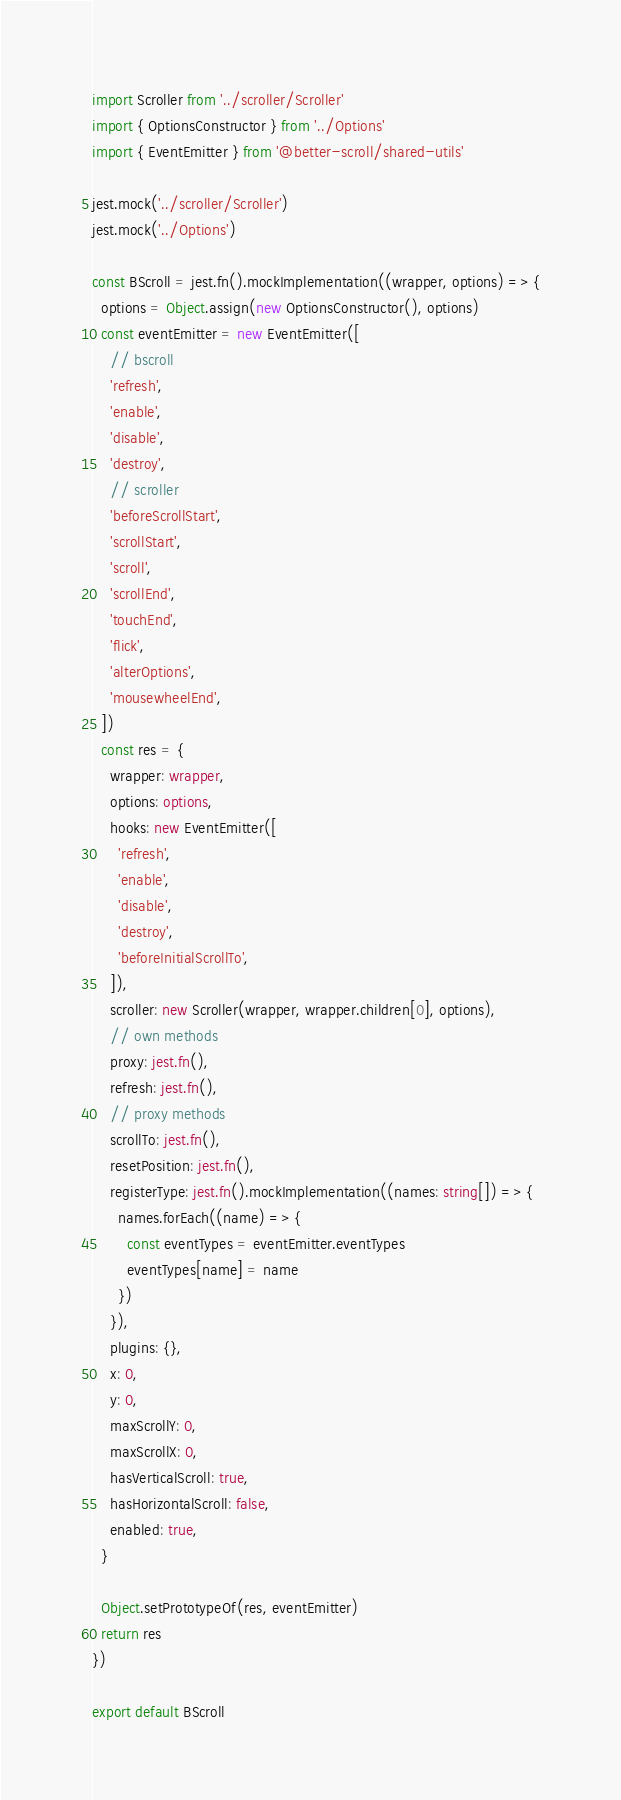<code> <loc_0><loc_0><loc_500><loc_500><_TypeScript_>import Scroller from '../scroller/Scroller'
import { OptionsConstructor } from '../Options'
import { EventEmitter } from '@better-scroll/shared-utils'

jest.mock('../scroller/Scroller')
jest.mock('../Options')

const BScroll = jest.fn().mockImplementation((wrapper, options) => {
  options = Object.assign(new OptionsConstructor(), options)
  const eventEmitter = new EventEmitter([
    // bscroll
    'refresh',
    'enable',
    'disable',
    'destroy',
    // scroller
    'beforeScrollStart',
    'scrollStart',
    'scroll',
    'scrollEnd',
    'touchEnd',
    'flick',
    'alterOptions',
    'mousewheelEnd',
  ])
  const res = {
    wrapper: wrapper,
    options: options,
    hooks: new EventEmitter([
      'refresh',
      'enable',
      'disable',
      'destroy',
      'beforeInitialScrollTo',
    ]),
    scroller: new Scroller(wrapper, wrapper.children[0], options),
    // own methods
    proxy: jest.fn(),
    refresh: jest.fn(),
    // proxy methods
    scrollTo: jest.fn(),
    resetPosition: jest.fn(),
    registerType: jest.fn().mockImplementation((names: string[]) => {
      names.forEach((name) => {
        const eventTypes = eventEmitter.eventTypes
        eventTypes[name] = name
      })
    }),
    plugins: {},
    x: 0,
    y: 0,
    maxScrollY: 0,
    maxScrollX: 0,
    hasVerticalScroll: true,
    hasHorizontalScroll: false,
    enabled: true,
  }

  Object.setPrototypeOf(res, eventEmitter)
  return res
})

export default BScroll
</code> 